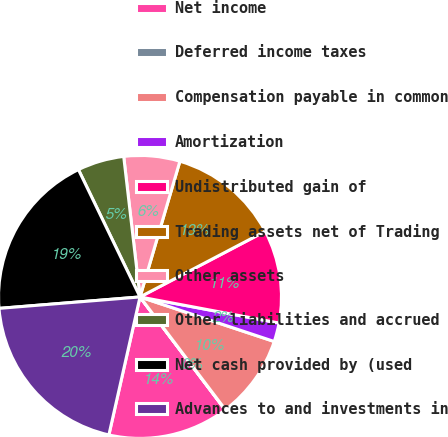Convert chart. <chart><loc_0><loc_0><loc_500><loc_500><pie_chart><fcel>Net income<fcel>Deferred income taxes<fcel>Compensation payable in common<fcel>Amortization<fcel>Undistributed gain of<fcel>Trading assets net of Trading<fcel>Other assets<fcel>Other liabilities and accrued<fcel>Net cash provided by (used<fcel>Advances to and investments in<nl><fcel>13.82%<fcel>0.03%<fcel>9.58%<fcel>2.15%<fcel>10.64%<fcel>12.76%<fcel>6.39%<fcel>5.33%<fcel>19.12%<fcel>20.18%<nl></chart> 